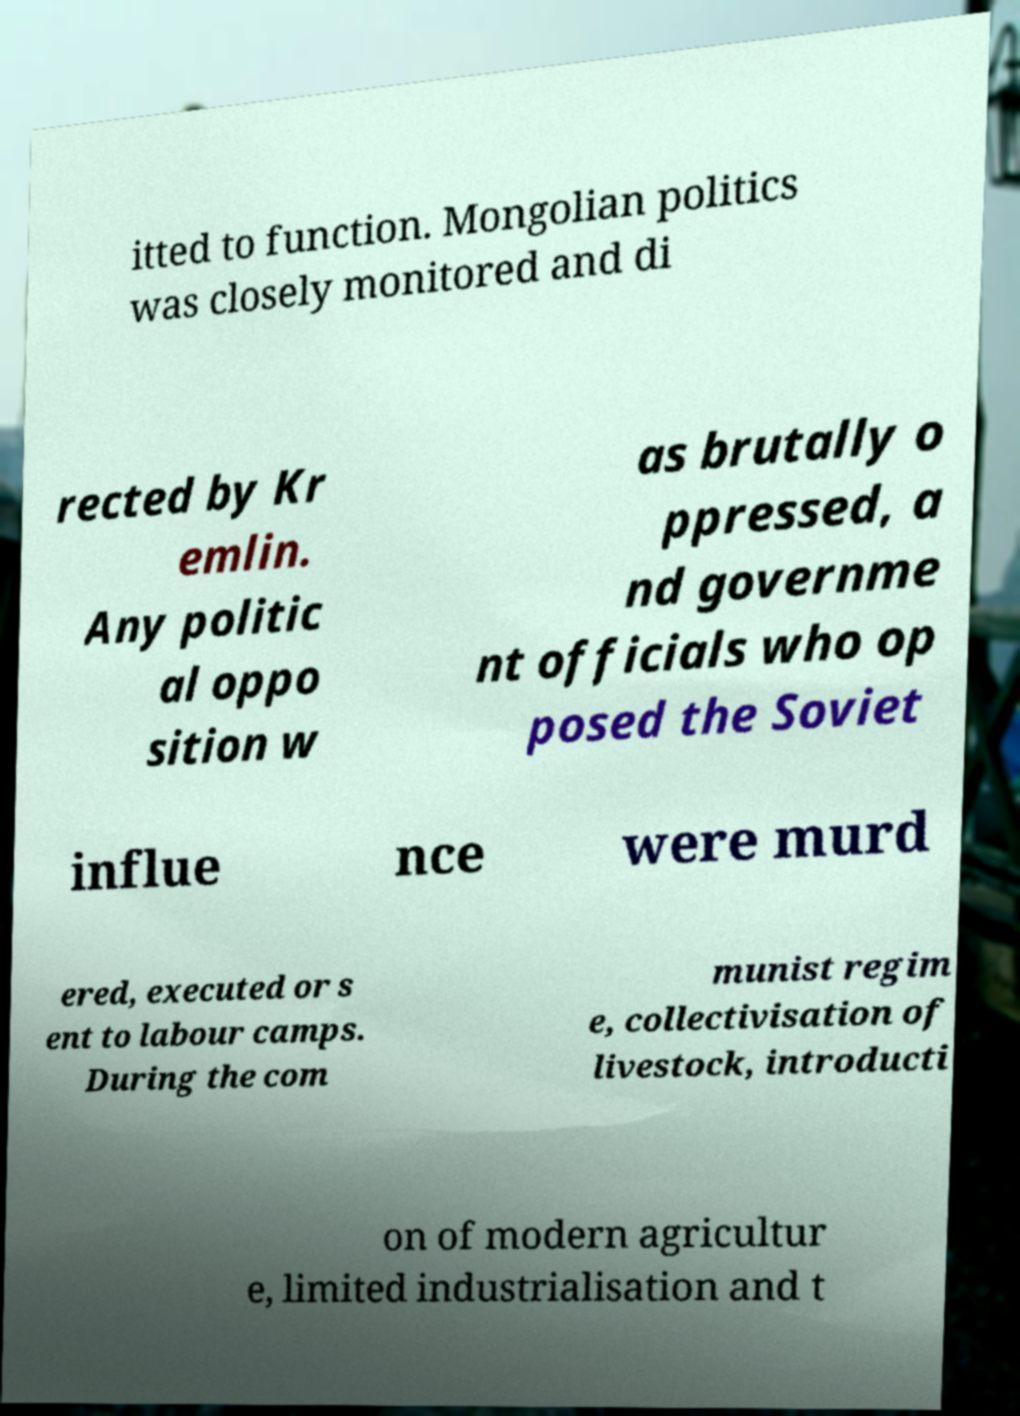What messages or text are displayed in this image? I need them in a readable, typed format. itted to function. Mongolian politics was closely monitored and di rected by Kr emlin. Any politic al oppo sition w as brutally o ppressed, a nd governme nt officials who op posed the Soviet influe nce were murd ered, executed or s ent to labour camps. During the com munist regim e, collectivisation of livestock, introducti on of modern agricultur e, limited industrialisation and t 